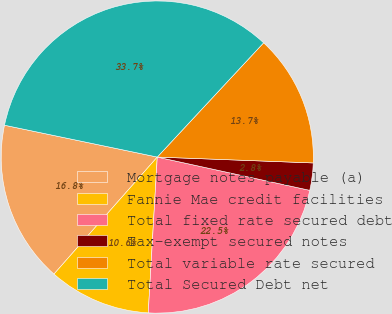Convert chart. <chart><loc_0><loc_0><loc_500><loc_500><pie_chart><fcel>Mortgage notes payable (a)<fcel>Fannie Mae credit facilities<fcel>Total fixed rate secured debt<fcel>Tax-exempt secured notes<fcel>Total variable rate secured<fcel>Total Secured Debt net<nl><fcel>16.76%<fcel>10.59%<fcel>22.5%<fcel>2.82%<fcel>13.67%<fcel>33.66%<nl></chart> 